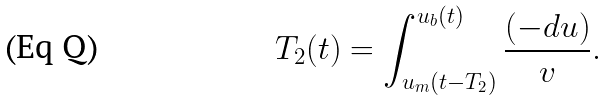Convert formula to latex. <formula><loc_0><loc_0><loc_500><loc_500>T _ { 2 } ( t ) = \int _ { u _ { m } ( t - T _ { 2 } ) } ^ { u _ { b } ( t ) } \frac { ( - d u ) } { v } .</formula> 